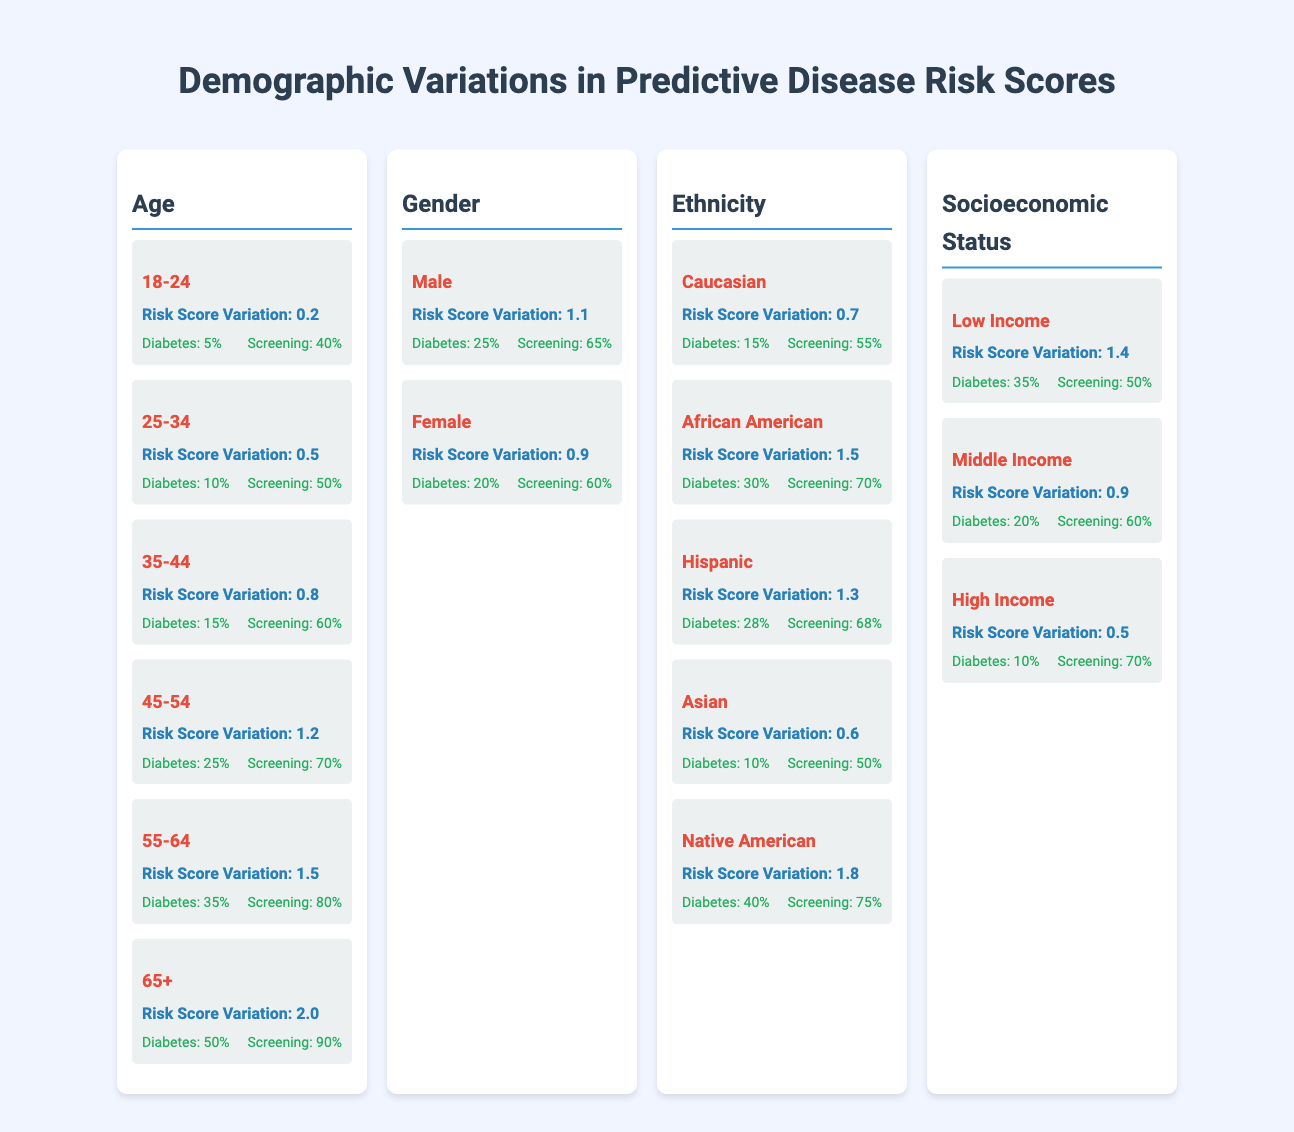What is the risk score variation for individuals aged 25-34? The table clearly shows that for the age range of 25-34, the risk score variation is 0.5.
Answer: 0.5 What is the probability of diabetes for females? According to the table, the probability of diabetes for females is 20%.
Answer: 20% Which age group has the highest screening rate? In the table, the age group 65+ has a screening rate of 90%, which is the highest among all age groups listed.
Answer: 65+ Is the risk score variation for Native Americans greater than for Asians? Yes, the risk score variation for Native Americans is 1.8, while for Asians it is 0.6. Therefore, it is indeed greater for Native Americans.
Answer: Yes What is the average probability of diabetes across all ethnic groups? To find the average, sum the probabilities: (15% + 30% + 28% + 10% + 40% = 123%), then divide by the number of groups (5): 123% / 5 = 24.6%.
Answer: 24.6% What is the risk score variation for the low-income group compared to the high-income group? The risk score variation for the low-income group is 1.4, while for the high-income group it is 0.5. 1.4 is greater than 0.5.
Answer: Low income > High income How does the screening rate for those aged 45-54 compare to the screening rate for males? The screening rate for those aged 45-54 is 70%, while for males it is 65%. Thus, the screening rate for 45-54 age group is higher.
Answer: 70% > 65% What factors contribute most to the increase in diabetes probability based on the table? The table shows that age, especially in the age group of 65+, contributes most significantly to increased probability of diabetes at 50%. Other factors such as low income and Native American ethnicity also have high probabilities but less than the highest age group.
Answer: Age contributes most 